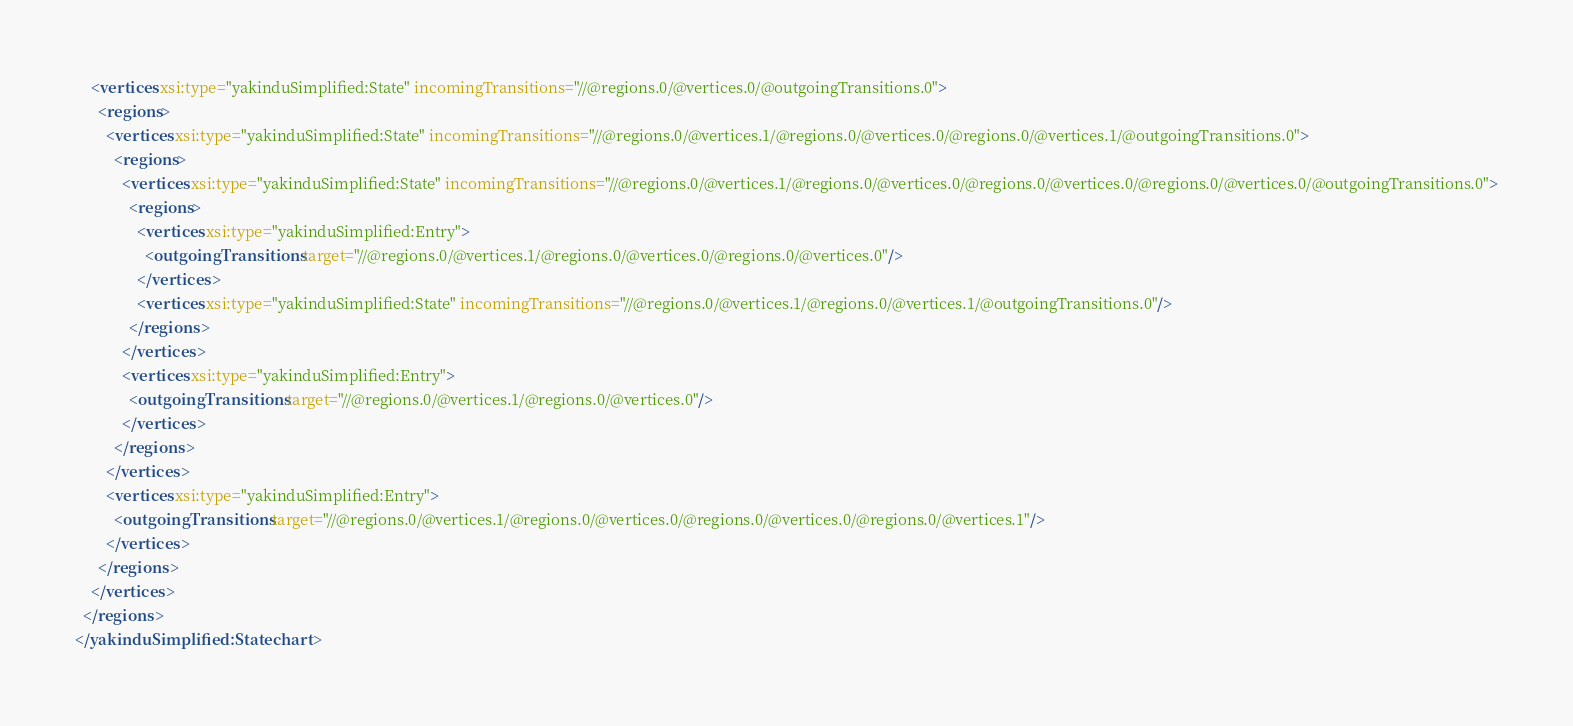Convert code to text. <code><loc_0><loc_0><loc_500><loc_500><_XML_>    <vertices xsi:type="yakinduSimplified:State" incomingTransitions="//@regions.0/@vertices.0/@outgoingTransitions.0">
      <regions>
        <vertices xsi:type="yakinduSimplified:State" incomingTransitions="//@regions.0/@vertices.1/@regions.0/@vertices.0/@regions.0/@vertices.1/@outgoingTransitions.0">
          <regions>
            <vertices xsi:type="yakinduSimplified:State" incomingTransitions="//@regions.0/@vertices.1/@regions.0/@vertices.0/@regions.0/@vertices.0/@regions.0/@vertices.0/@outgoingTransitions.0">
              <regions>
                <vertices xsi:type="yakinduSimplified:Entry">
                  <outgoingTransitions target="//@regions.0/@vertices.1/@regions.0/@vertices.0/@regions.0/@vertices.0"/>
                </vertices>
                <vertices xsi:type="yakinduSimplified:State" incomingTransitions="//@regions.0/@vertices.1/@regions.0/@vertices.1/@outgoingTransitions.0"/>
              </regions>
            </vertices>
            <vertices xsi:type="yakinduSimplified:Entry">
              <outgoingTransitions target="//@regions.0/@vertices.1/@regions.0/@vertices.0"/>
            </vertices>
          </regions>
        </vertices>
        <vertices xsi:type="yakinduSimplified:Entry">
          <outgoingTransitions target="//@regions.0/@vertices.1/@regions.0/@vertices.0/@regions.0/@vertices.0/@regions.0/@vertices.1"/>
        </vertices>
      </regions>
    </vertices>
  </regions>
</yakinduSimplified:Statechart>
</code> 